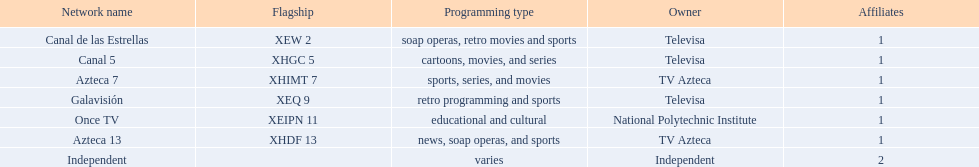Which proprietor possesses just a single network? National Polytechnic Institute, Independent. Parse the full table. {'header': ['Network name', 'Flagship', 'Programming type', 'Owner', 'Affiliates'], 'rows': [['Canal de las Estrellas', 'XEW 2', 'soap operas, retro movies and sports', 'Televisa', '1'], ['Canal 5', 'XHGC 5', 'cartoons, movies, and series', 'Televisa', '1'], ['Azteca 7', 'XHIMT 7', 'sports, series, and movies', 'TV Azteca', '1'], ['Galavisión', 'XEQ 9', 'retro programming and sports', 'Televisa', '1'], ['Once TV', 'XEIPN 11', 'educational and cultural', 'National Polytechnic Institute', '1'], ['Azteca 13', 'XHDF 13', 'news, soap operas, and sports', 'TV Azteca', '1'], ['Independent', '', 'varies', 'Independent', '2']]} Among them, what is the name of that network? Once TV, Independent. Furthermore, which one focuses on educational and cultural content? Once TV. 